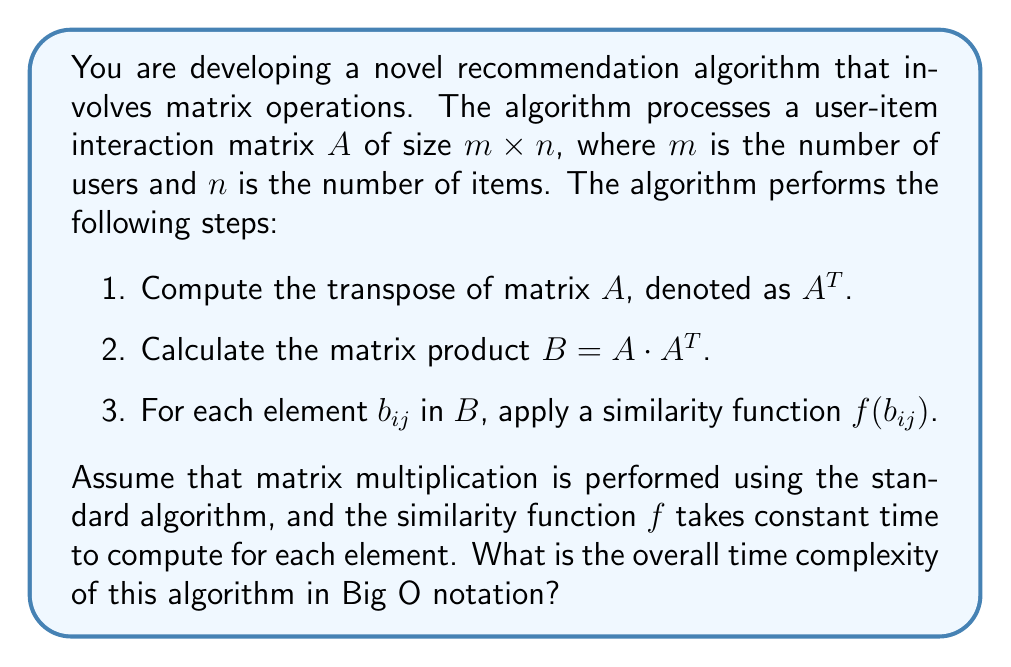Teach me how to tackle this problem. Let's analyze the time complexity of each step:

1. Computing the transpose $A^T$:
   - This operation requires iterating through each element of $A$ once.
   - Time complexity: $O(mn)$

2. Calculating the matrix product $B = A \cdot A^T$:
   - $A$ is of size $m \times n$, and $A^T$ is of size $n \times m$.
   - The resulting matrix $B$ will be of size $m \times m$.
   - For each element in $B$, we need to perform $n$ multiplications and $n-1$ additions.
   - Total number of operations: $m \cdot m \cdot n = m^2n$
   - Time complexity: $O(m^2n)$

3. Applying the similarity function $f(b_{ij})$:
   - We need to apply $f$ to each element of $B$.
   - $B$ is of size $m \times m$, so there are $m^2$ elements.
   - Since $f$ takes constant time, this step has a time complexity of $O(m^2)$.

To determine the overall time complexity, we add the complexities of each step and keep the dominant term:

$$O(mn) + O(m^2n) + O(m^2)$$

Since $m^2n$ is the largest term (assuming $m$ and $n$ are large), the overall time complexity is $O(m^2n)$.
Answer: $O(m^2n)$ 